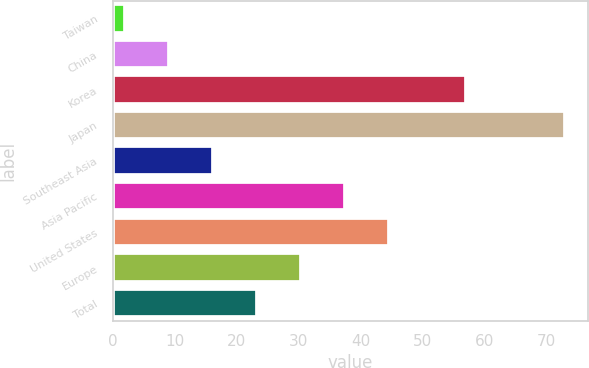<chart> <loc_0><loc_0><loc_500><loc_500><bar_chart><fcel>Taiwan<fcel>China<fcel>Korea<fcel>Japan<fcel>Southeast Asia<fcel>Asia Pacific<fcel>United States<fcel>Europe<fcel>Total<nl><fcel>2<fcel>9.1<fcel>57<fcel>73<fcel>16.2<fcel>37.5<fcel>44.6<fcel>30.4<fcel>23.3<nl></chart> 